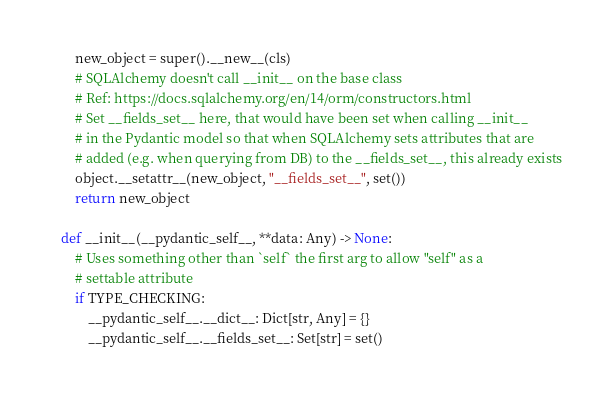<code> <loc_0><loc_0><loc_500><loc_500><_Python_>        new_object = super().__new__(cls)
        # SQLAlchemy doesn't call __init__ on the base class
        # Ref: https://docs.sqlalchemy.org/en/14/orm/constructors.html
        # Set __fields_set__ here, that would have been set when calling __init__
        # in the Pydantic model so that when SQLAlchemy sets attributes that are
        # added (e.g. when querying from DB) to the __fields_set__, this already exists
        object.__setattr__(new_object, "__fields_set__", set())
        return new_object

    def __init__(__pydantic_self__, **data: Any) -> None:
        # Uses something other than `self` the first arg to allow "self" as a
        # settable attribute
        if TYPE_CHECKING:
            __pydantic_self__.__dict__: Dict[str, Any] = {}
            __pydantic_self__.__fields_set__: Set[str] = set()</code> 